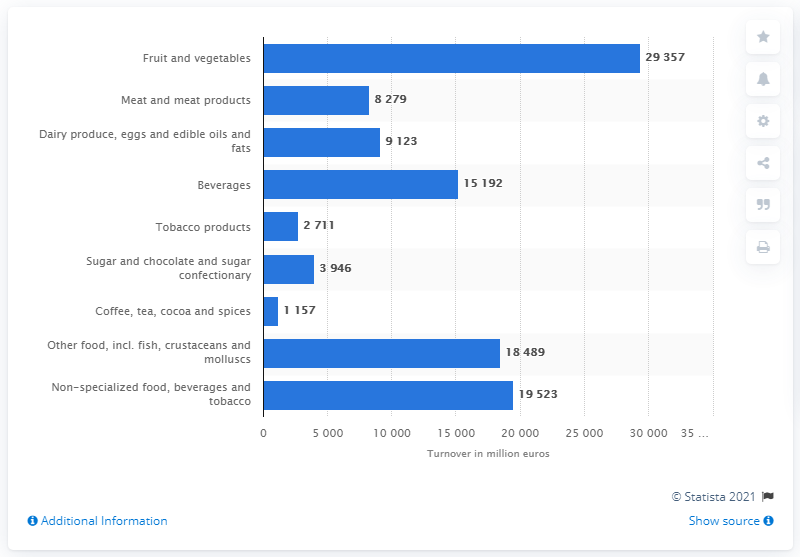Outline some significant characteristics in this image. The total tobacco product revenue in Spain in 2014 was 2,711. 